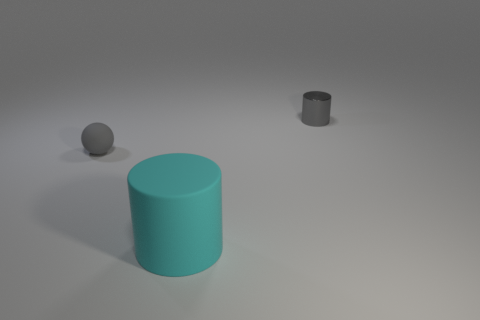Add 1 small red matte cubes. How many objects exist? 4 Subtract 0 red cubes. How many objects are left? 3 Subtract all balls. How many objects are left? 2 Subtract all yellow matte cylinders. Subtract all big matte things. How many objects are left? 2 Add 2 cyan matte objects. How many cyan matte objects are left? 3 Add 1 tiny gray balls. How many tiny gray balls exist? 2 